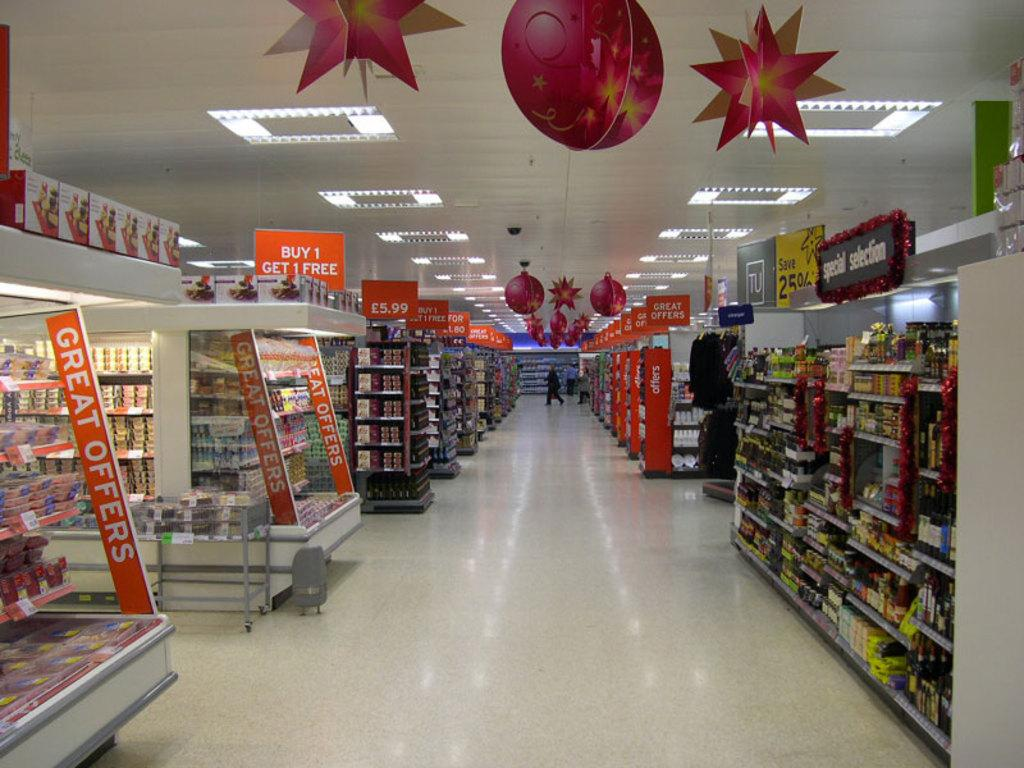<image>
Present a compact description of the photo's key features. The black sign to the right of the isle reads Special Selection 